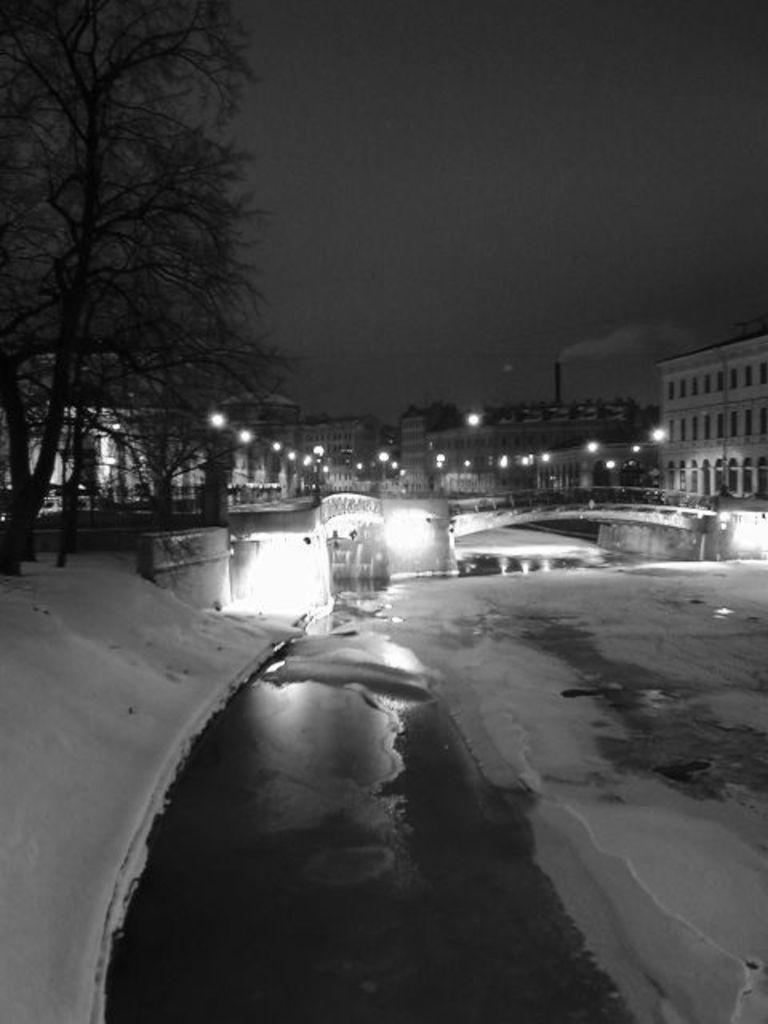What structure is present in the image? There is a bridge in the image. What natural element is visible in the image? There is water in the image. What is the unusual feature present in the water? There is ice in the image. What can be seen in the distance in the image? There are buildings, lights, and trees in the background of the image. What is visible at the top of the image? The sky is visible at the top of the image. Where is the drawer located in the image? There is no drawer present in the image. What type of prose can be heard in the background of the image? There is no prose or any audible content in the image, as it is a still photograph. 